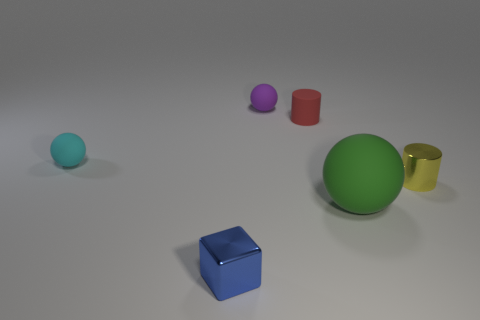Add 1 small purple matte objects. How many objects exist? 7 Subtract all blocks. How many objects are left? 5 Subtract 0 blue cylinders. How many objects are left? 6 Subtract all small purple rubber spheres. Subtract all green balls. How many objects are left? 4 Add 3 green balls. How many green balls are left? 4 Add 5 large brown matte objects. How many large brown matte objects exist? 5 